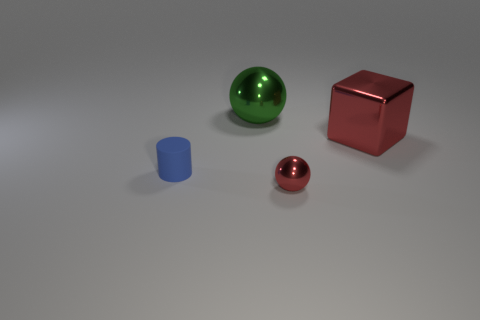How many metal objects are either tiny balls or blue objects?
Provide a succinct answer. 1. The shiny object that is both behind the tiny rubber thing and to the left of the large block is what color?
Provide a succinct answer. Green. There is a metal ball behind the red sphere; does it have the same size as the red metal block?
Ensure brevity in your answer.  Yes. How many things are red metal objects that are behind the tiny red thing or small cyan cubes?
Your response must be concise. 1. Is there another matte cylinder of the same size as the blue matte cylinder?
Give a very brief answer. No. There is a cube that is the same size as the green metallic object; what is it made of?
Ensure brevity in your answer.  Metal. There is a shiny object that is both to the left of the big red metal cube and behind the small red metallic sphere; what is its shape?
Your answer should be very brief. Sphere. The sphere in front of the red cube is what color?
Keep it short and to the point. Red. How big is the object that is in front of the cube and behind the small ball?
Your response must be concise. Small. Are the small red ball and the small object on the left side of the tiny red object made of the same material?
Your response must be concise. No. 